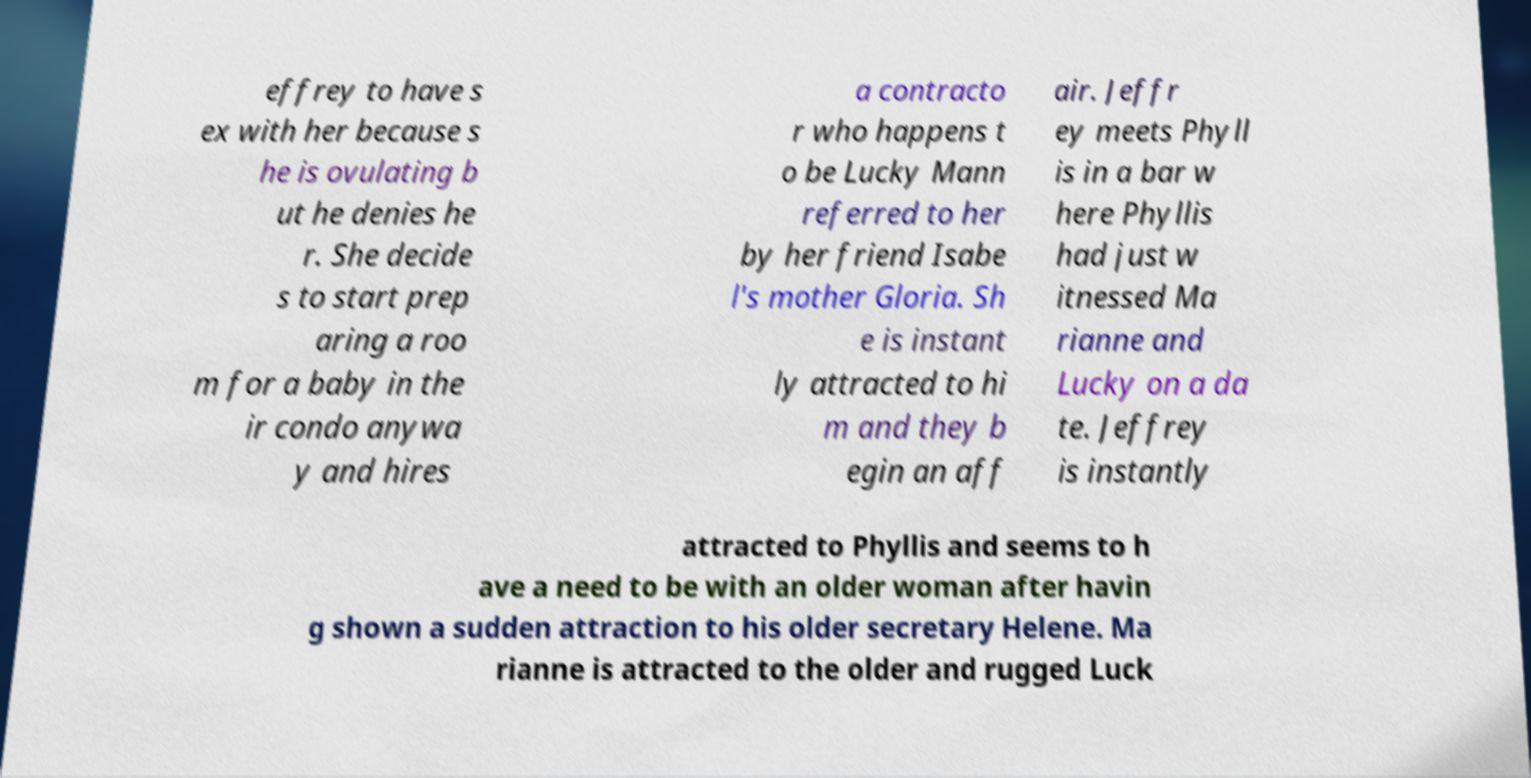Can you accurately transcribe the text from the provided image for me? effrey to have s ex with her because s he is ovulating b ut he denies he r. She decide s to start prep aring a roo m for a baby in the ir condo anywa y and hires a contracto r who happens t o be Lucky Mann referred to her by her friend Isabe l's mother Gloria. Sh e is instant ly attracted to hi m and they b egin an aff air. Jeffr ey meets Phyll is in a bar w here Phyllis had just w itnessed Ma rianne and Lucky on a da te. Jeffrey is instantly attracted to Phyllis and seems to h ave a need to be with an older woman after havin g shown a sudden attraction to his older secretary Helene. Ma rianne is attracted to the older and rugged Luck 